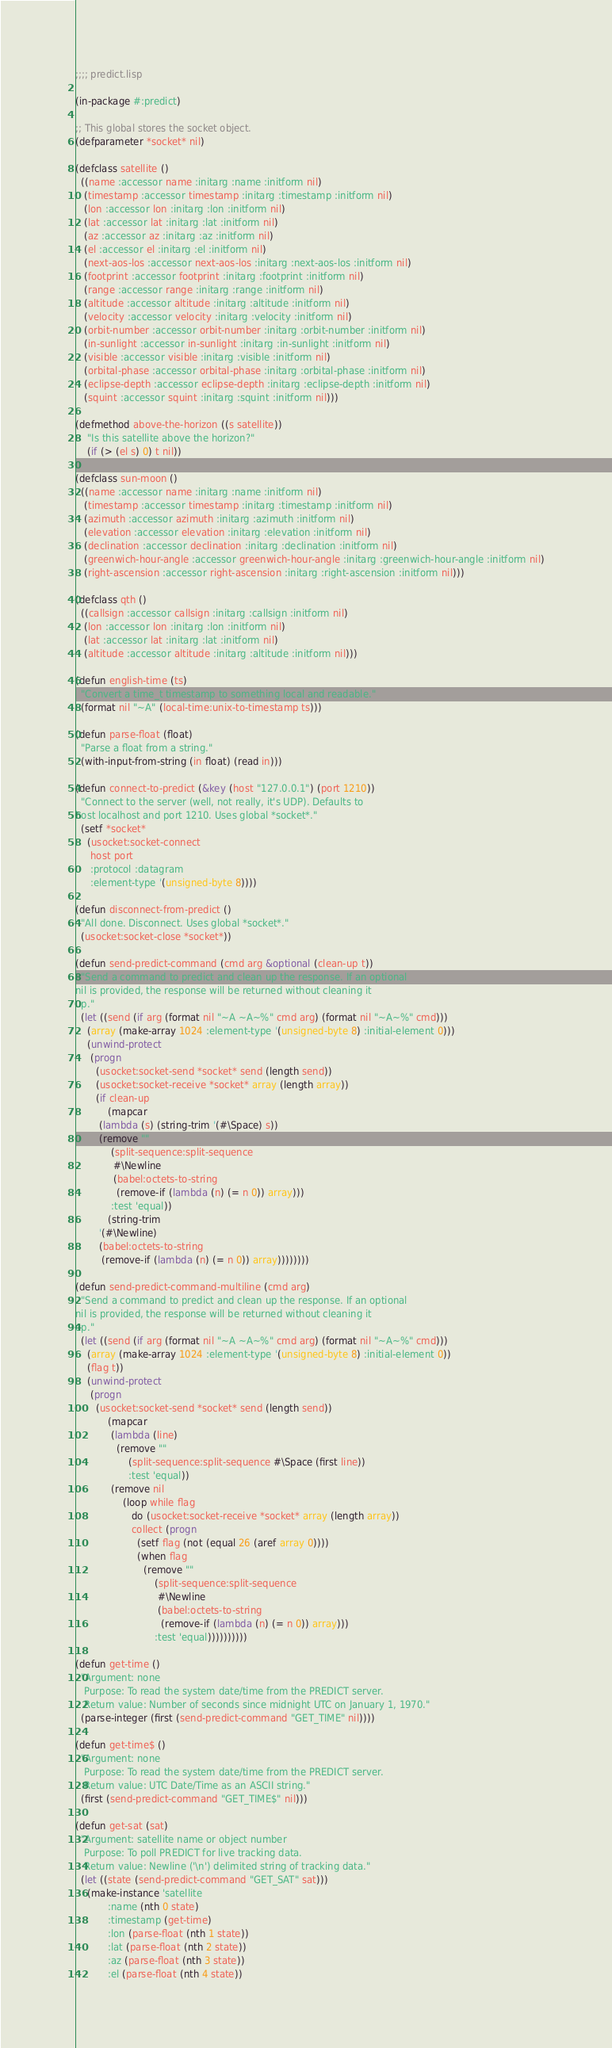Convert code to text. <code><loc_0><loc_0><loc_500><loc_500><_Lisp_>;;;; predict.lisp

(in-package #:predict)

;; This global stores the socket object.
(defparameter *socket* nil)

(defclass satellite ()
  ((name :accessor name :initarg :name :initform nil)
   (timestamp :accessor timestamp :initarg :timestamp :initform nil)
   (lon :accessor lon :initarg :lon :initform nil)
   (lat :accessor lat :initarg :lat :initform nil)
   (az :accessor az :initarg :az :initform nil)
   (el :accessor el :initarg :el :initform nil)
   (next-aos-los :accessor next-aos-los :initarg :next-aos-los :initform nil)
   (footprint :accessor footprint :initarg :footprint :initform nil)
   (range :accessor range :initarg :range :initform nil)
   (altitude :accessor altitude :initarg :altitude :initform nil)
   (velocity :accessor velocity :initarg :velocity :initform nil)
   (orbit-number :accessor orbit-number :initarg :orbit-number :initform nil)
   (in-sunlight :accessor in-sunlight :initarg :in-sunlight :initform nil)
   (visible :accessor visible :initarg :visible :initform nil)
   (orbital-phase :accessor orbital-phase :initarg :orbital-phase :initform nil)
   (eclipse-depth :accessor eclipse-depth :initarg :eclipse-depth :initform nil)
   (squint :accessor squint :initarg :squint :initform nil)))

(defmethod above-the-horizon ((s satellite))
    "Is this satellite above the horizon?"
    (if (> (el s) 0) t nil))

(defclass sun-moon ()
  ((name :accessor name :initarg :name :initform nil)
   (timestamp :accessor timestamp :initarg :timestamp :initform nil)
   (azimuth :accessor azimuth :initarg :azimuth :initform nil)
   (elevation :accessor elevation :initarg :elevation :initform nil)
   (declination :accessor declination :initarg :declination :initform nil)
   (greenwich-hour-angle :accessor greenwich-hour-angle :initarg :greenwich-hour-angle :initform nil)
   (right-ascension :accessor right-ascension :initarg :right-ascension :initform nil)))

(defclass qth ()
  ((callsign :accessor callsign :initarg :callsign :initform nil)
   (lon :accessor lon :initarg :lon :initform nil)
   (lat :accessor lat :initarg :lat :initform nil)
   (altitude :accessor altitude :initarg :altitude :initform nil)))

(defun english-time (ts)
  "Convert a time_t timestamp to something local and readable."
  (format nil "~A" (local-time:unix-to-timestamp ts)))

(defun parse-float (float)
  "Parse a float from a string."
  (with-input-from-string (in float) (read in)))

(defun connect-to-predict (&key (host "127.0.0.1") (port 1210))
  "Connect to the server (well, not really, it's UDP). Defaults to
host localhost and port 1210. Uses global *socket*."
  (setf *socket*
	(usocket:socket-connect
	 host port
	 :protocol :datagram
	 :element-type '(unsigned-byte 8))))

(defun disconnect-from-predict ()
  "All done. Disconnect. Uses global *socket*."
  (usocket:socket-close *socket*))

(defun send-predict-command (cmd arg &optional (clean-up t))
  "Send a command to predict and clean up the response. If an optional
nil is provided, the response will be returned without cleaning it
up."
  (let ((send (if arg (format nil "~A ~A~%" cmd arg) (format nil "~A~%" cmd)))
	(array (make-array 1024 :element-type '(unsigned-byte 8) :initial-element 0)))
    (unwind-protect
	 (progn
	   (usocket:socket-send *socket* send (length send))
	   (usocket:socket-receive *socket* array (length array))
	   (if clean-up
	       (mapcar
		(lambda (s) (string-trim '(#\Space) s))
		(remove ""
			(split-sequence:split-sequence
			 #\Newline
			 (babel:octets-to-string
			  (remove-if (lambda (n) (= n 0)) array)))
			:test 'equal))
	       (string-trim
		'(#\Newline)
		(babel:octets-to-string
		 (remove-if (lambda (n) (= n 0)) array))))))))

(defun send-predict-command-multiline (cmd arg)
  "Send a command to predict and clean up the response. If an optional
nil is provided, the response will be returned without cleaning it
up."
  (let ((send (if arg (format nil "~A ~A~%" cmd arg) (format nil "~A~%" cmd)))
	(array (make-array 1024 :element-type '(unsigned-byte 8) :initial-element 0))
	(flag t))
    (unwind-protect
	 (progn
	   (usocket:socket-send *socket* send (length send))
		   (mapcar
		    (lambda (line)
		      (remove ""
			      (split-sequence:split-sequence #\Space (first line))
			      :test 'equal))
		    (remove nil
			    (loop while flag
			       do (usocket:socket-receive *socket* array (length array))
			       collect (progn
					 (setf flag (not (equal 26 (aref array 0))))
					 (when flag
					   (remove ""
						   (split-sequence:split-sequence
						    #\Newline
						    (babel:octets-to-string
						     (remove-if (lambda (n) (= n 0)) array)))
						   :test 'equal))))))))))

(defun get-time ()
  "Argument: none
   Purpose: To read the system date/time from the PREDICT server.
   Return value: Number of seconds since midnight UTC on January 1, 1970."
  (parse-integer (first (send-predict-command "GET_TIME" nil))))

(defun get-time$ ()
  "Argument: none
   Purpose: To read the system date/time from the PREDICT server.
   Return value: UTC Date/Time as an ASCII string."
  (first (send-predict-command "GET_TIME$" nil)))

(defun get-sat (sat)
  "Argument: satellite name or object number
   Purpose: To poll PREDICT for live tracking data.
   Return value: Newline ('\n') delimited string of tracking data."
  (let ((state (send-predict-command "GET_SAT" sat)))
    (make-instance 'satellite
		   :name (nth 0 state)
		   :timestamp (get-time)
		   :lon (parse-float (nth 1 state))
		   :lat (parse-float (nth 2 state))
		   :az (parse-float (nth 3 state))
		   :el (parse-float (nth 4 state))</code> 